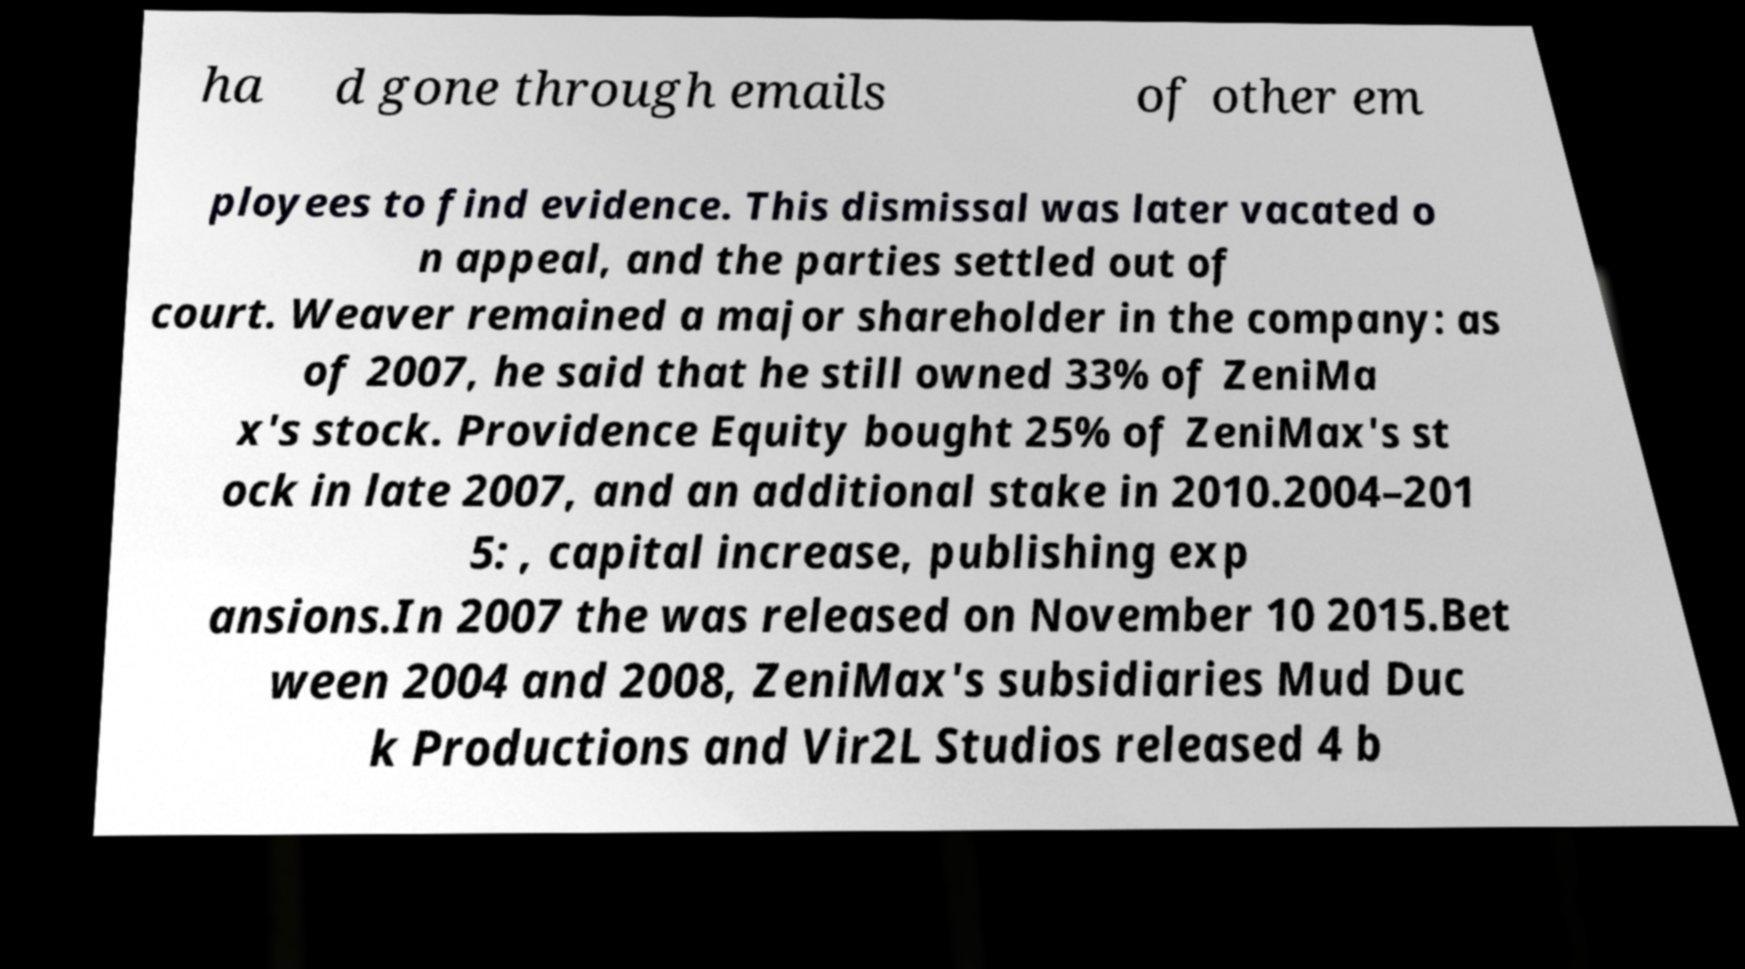Could you assist in decoding the text presented in this image and type it out clearly? ha d gone through emails of other em ployees to find evidence. This dismissal was later vacated o n appeal, and the parties settled out of court. Weaver remained a major shareholder in the company: as of 2007, he said that he still owned 33% of ZeniMa x's stock. Providence Equity bought 25% of ZeniMax's st ock in late 2007, and an additional stake in 2010.2004–201 5: , capital increase, publishing exp ansions.In 2007 the was released on November 10 2015.Bet ween 2004 and 2008, ZeniMax's subsidiaries Mud Duc k Productions and Vir2L Studios released 4 b 